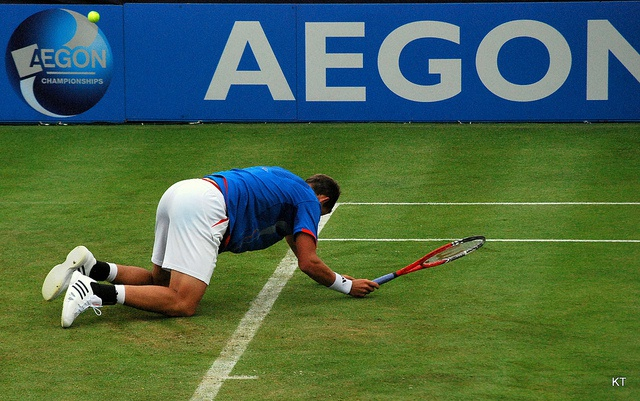Describe the objects in this image and their specific colors. I can see people in black, lightgray, maroon, and navy tones, tennis racket in black, darkgreen, gray, and maroon tones, and sports ball in black, yellow, lime, and green tones in this image. 